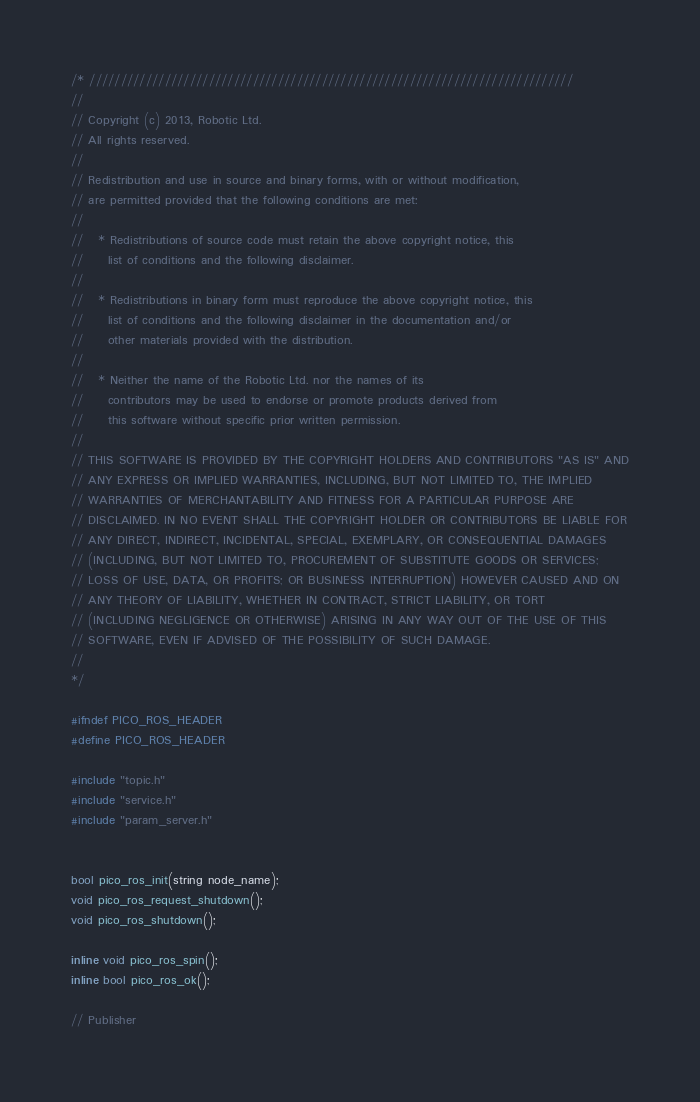<code> <loc_0><loc_0><loc_500><loc_500><_C_>/* /////////////////////////////////////////////////////////////////////////////
//
// Copyright (c) 2013, Robotic Ltd.
// All rights reserved.
//
// Redistribution and use in source and binary forms, with or without modification,
// are permitted provided that the following conditions are met:
//
//   * Redistributions of source code must retain the above copyright notice, this
//     list of conditions and the following disclaimer.
//
//   * Redistributions in binary form must reproduce the above copyright notice, this
//     list of conditions and the following disclaimer in the documentation and/or
//     other materials provided with the distribution.
//
//   * Neither the name of the Robotic Ltd. nor the names of its
//     contributors may be used to endorse or promote products derived from
//     this software without specific prior written permission.
//
// THIS SOFTWARE IS PROVIDED BY THE COPYRIGHT HOLDERS AND CONTRIBUTORS "AS IS" AND
// ANY EXPRESS OR IMPLIED WARRANTIES, INCLUDING, BUT NOT LIMITED TO, THE IMPLIED
// WARRANTIES OF MERCHANTABILITY AND FITNESS FOR A PARTICULAR PURPOSE ARE
// DISCLAIMED. IN NO EVENT SHALL THE COPYRIGHT HOLDER OR CONTRIBUTORS BE LIABLE FOR
// ANY DIRECT, INDIRECT, INCIDENTAL, SPECIAL, EXEMPLARY, OR CONSEQUENTIAL DAMAGES
// (INCLUDING, BUT NOT LIMITED TO, PROCUREMENT OF SUBSTITUTE GOODS OR SERVICES;
// LOSS OF USE, DATA, OR PROFITS; OR BUSINESS INTERRUPTION) HOWEVER CAUSED AND ON
// ANY THEORY OF LIABILITY, WHETHER IN CONTRACT, STRICT LIABILITY, OR TORT
// (INCLUDING NEGLIGENCE OR OTHERWISE) ARISING IN ANY WAY OUT OF THE USE OF THIS
// SOFTWARE, EVEN IF ADVISED OF THE POSSIBILITY OF SUCH DAMAGE.
//
*/

#ifndef PICO_ROS_HEADER
#define PICO_ROS_HEADER

#include "topic.h"
#include "service.h"
#include "param_server.h"


bool pico_ros_init(string node_name);
void pico_ros_request_shutdown();
void pico_ros_shutdown();

inline void pico_ros_spin();
inline bool pico_ros_ok();

// Publisher</code> 